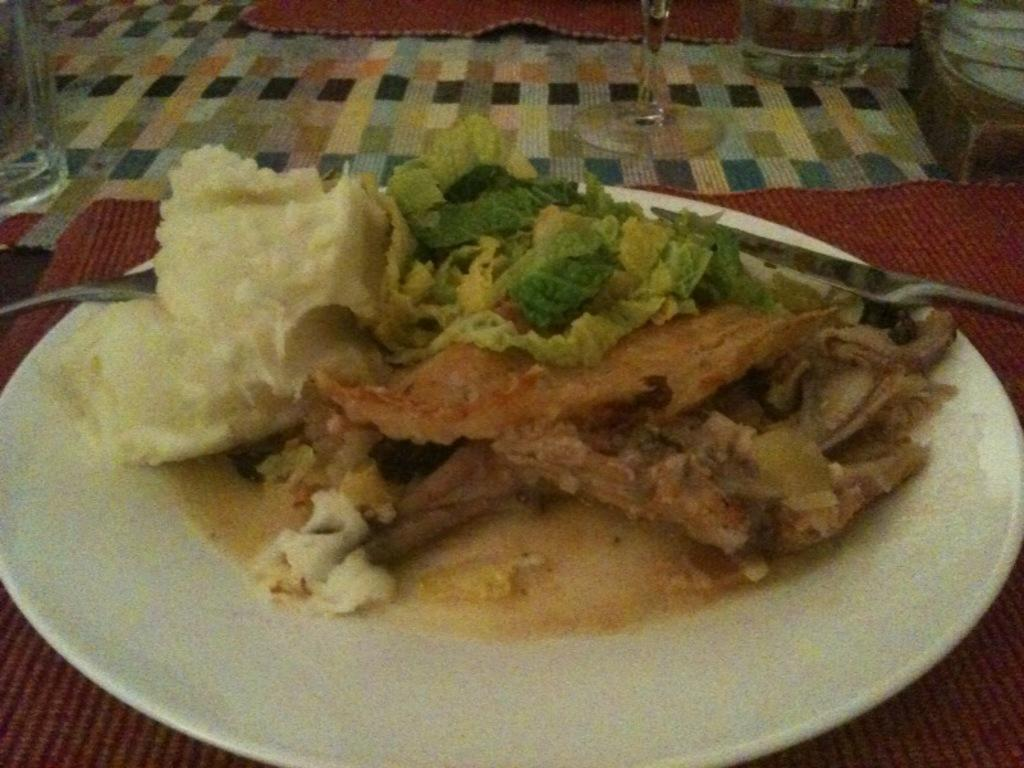What is located in the center of the image? There is a plate in the center of the image. What is on the plate? The plate contains food items. Where are the glasses located in the image? The glasses are at the top side of the image. What type of bomb can be seen in the image? There is no bomb present in the image. Is there a fire visible in the image? There is no fire visible in the image. 